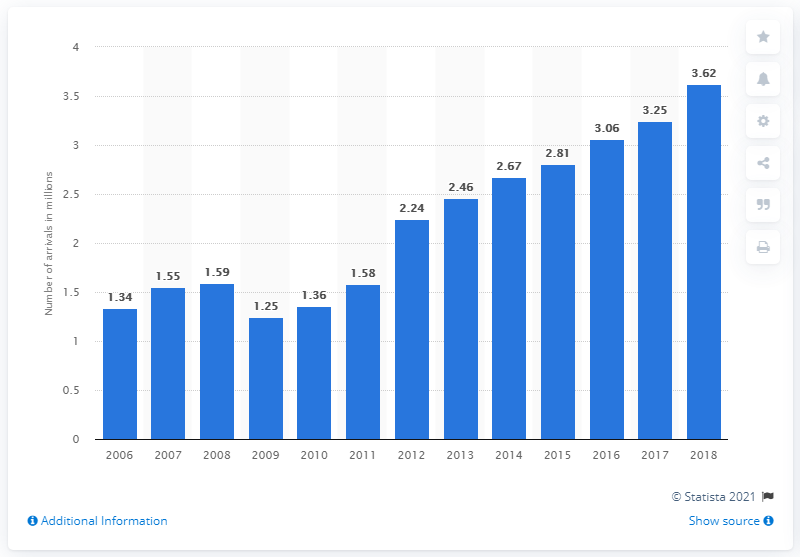List a handful of essential elements in this visual. In 2018, a total of 3.62 people arrived in Lithuania. 